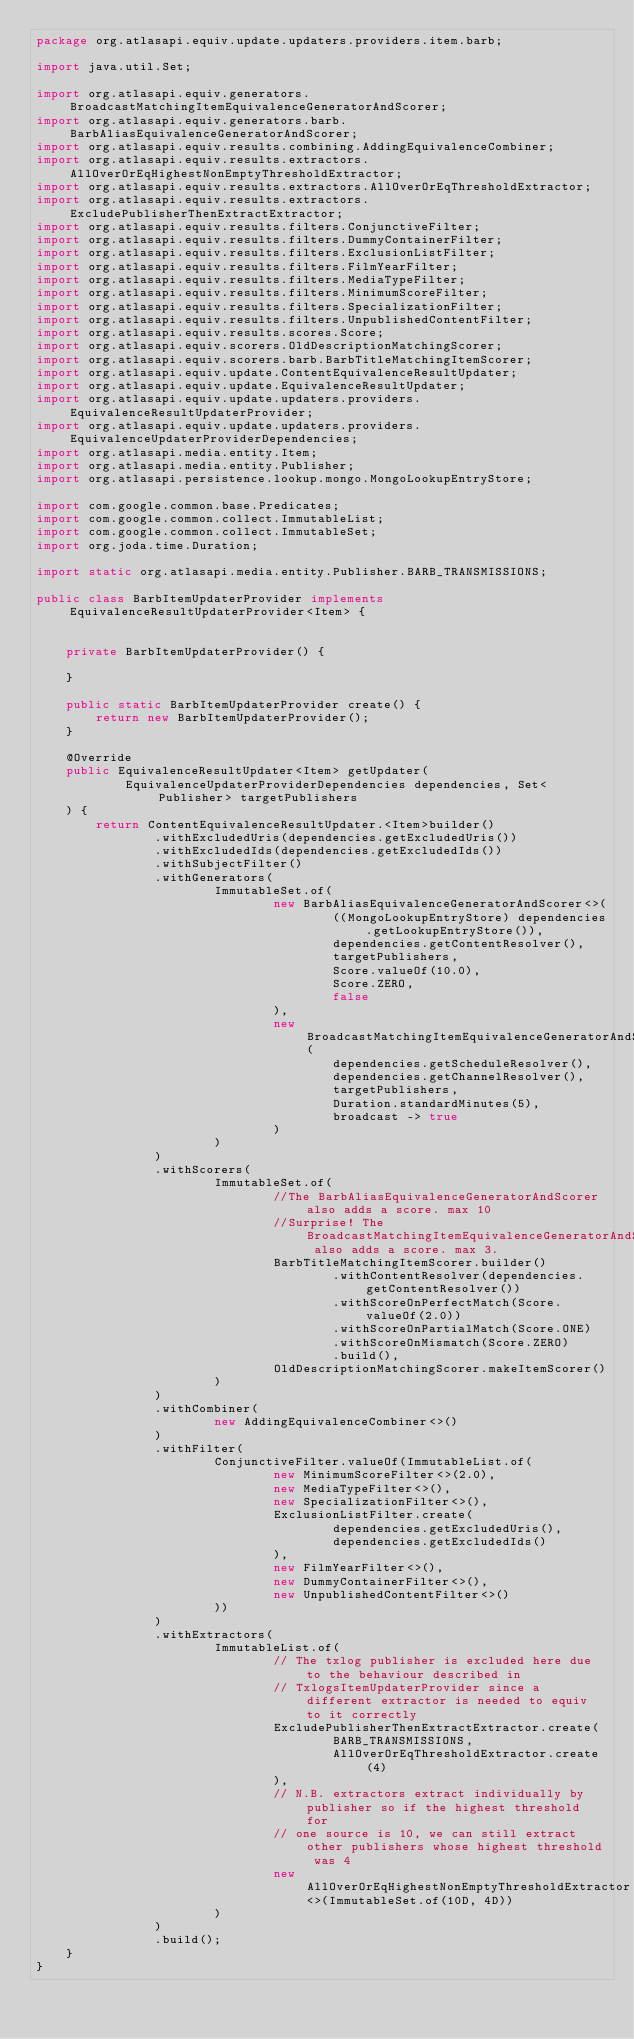<code> <loc_0><loc_0><loc_500><loc_500><_Java_>package org.atlasapi.equiv.update.updaters.providers.item.barb;

import java.util.Set;

import org.atlasapi.equiv.generators.BroadcastMatchingItemEquivalenceGeneratorAndScorer;
import org.atlasapi.equiv.generators.barb.BarbAliasEquivalenceGeneratorAndScorer;
import org.atlasapi.equiv.results.combining.AddingEquivalenceCombiner;
import org.atlasapi.equiv.results.extractors.AllOverOrEqHighestNonEmptyThresholdExtractor;
import org.atlasapi.equiv.results.extractors.AllOverOrEqThresholdExtractor;
import org.atlasapi.equiv.results.extractors.ExcludePublisherThenExtractExtractor;
import org.atlasapi.equiv.results.filters.ConjunctiveFilter;
import org.atlasapi.equiv.results.filters.DummyContainerFilter;
import org.atlasapi.equiv.results.filters.ExclusionListFilter;
import org.atlasapi.equiv.results.filters.FilmYearFilter;
import org.atlasapi.equiv.results.filters.MediaTypeFilter;
import org.atlasapi.equiv.results.filters.MinimumScoreFilter;
import org.atlasapi.equiv.results.filters.SpecializationFilter;
import org.atlasapi.equiv.results.filters.UnpublishedContentFilter;
import org.atlasapi.equiv.results.scores.Score;
import org.atlasapi.equiv.scorers.OldDescriptionMatchingScorer;
import org.atlasapi.equiv.scorers.barb.BarbTitleMatchingItemScorer;
import org.atlasapi.equiv.update.ContentEquivalenceResultUpdater;
import org.atlasapi.equiv.update.EquivalenceResultUpdater;
import org.atlasapi.equiv.update.updaters.providers.EquivalenceResultUpdaterProvider;
import org.atlasapi.equiv.update.updaters.providers.EquivalenceUpdaterProviderDependencies;
import org.atlasapi.media.entity.Item;
import org.atlasapi.media.entity.Publisher;
import org.atlasapi.persistence.lookup.mongo.MongoLookupEntryStore;

import com.google.common.base.Predicates;
import com.google.common.collect.ImmutableList;
import com.google.common.collect.ImmutableSet;
import org.joda.time.Duration;

import static org.atlasapi.media.entity.Publisher.BARB_TRANSMISSIONS;

public class BarbItemUpdaterProvider implements EquivalenceResultUpdaterProvider<Item> {


    private BarbItemUpdaterProvider() {

    }

    public static BarbItemUpdaterProvider create() {
        return new BarbItemUpdaterProvider();
    }

    @Override
    public EquivalenceResultUpdater<Item> getUpdater(
            EquivalenceUpdaterProviderDependencies dependencies, Set<Publisher> targetPublishers
    ) {
        return ContentEquivalenceResultUpdater.<Item>builder()
                .withExcludedUris(dependencies.getExcludedUris())
                .withExcludedIds(dependencies.getExcludedIds())
                .withSubjectFilter()
                .withGenerators(
                        ImmutableSet.of(
                                new BarbAliasEquivalenceGeneratorAndScorer<>(
                                        ((MongoLookupEntryStore) dependencies.getLookupEntryStore()),
                                        dependencies.getContentResolver(),
                                        targetPublishers,
                                        Score.valueOf(10.0),
                                        Score.ZERO,
                                        false
                                ),
                                new BroadcastMatchingItemEquivalenceGeneratorAndScorer(
                                        dependencies.getScheduleResolver(),
                                        dependencies.getChannelResolver(),
                                        targetPublishers,
                                        Duration.standardMinutes(5),
                                        broadcast -> true
                                )
                        )
                )
                .withScorers(
                        ImmutableSet.of(
                                //The BarbAliasEquivalenceGeneratorAndScorer also adds a score. max 10
                                //Surprise! The BroadcastMatchingItemEquivalenceGeneratorAndScorer also adds a score. max 3.
                                BarbTitleMatchingItemScorer.builder()
                                        .withContentResolver(dependencies.getContentResolver())
                                        .withScoreOnPerfectMatch(Score.valueOf(2.0))
                                        .withScoreOnPartialMatch(Score.ONE)
                                        .withScoreOnMismatch(Score.ZERO)
                                        .build(),
                                OldDescriptionMatchingScorer.makeItemScorer()
                        )
                )
                .withCombiner(
                        new AddingEquivalenceCombiner<>()
                )
                .withFilter(
                        ConjunctiveFilter.valueOf(ImmutableList.of(
                                new MinimumScoreFilter<>(2.0),
                                new MediaTypeFilter<>(),
                                new SpecializationFilter<>(),
                                ExclusionListFilter.create(
                                        dependencies.getExcludedUris(),
                                        dependencies.getExcludedIds()
                                ),
                                new FilmYearFilter<>(),
                                new DummyContainerFilter<>(),
                                new UnpublishedContentFilter<>()
                        ))
                )
                .withExtractors(
                        ImmutableList.of(
                                // The txlog publisher is excluded here due to the behaviour described in
                                // TxlogsItemUpdaterProvider since a different extractor is needed to equiv to it correctly
                                ExcludePublisherThenExtractExtractor.create(
                                        BARB_TRANSMISSIONS,
                                        AllOverOrEqThresholdExtractor.create(4)
                                ),
                                // N.B. extractors extract individually by publisher so if the highest threshold for
                                // one source is 10, we can still extract other publishers whose highest threshold was 4
                                new AllOverOrEqHighestNonEmptyThresholdExtractor<>(ImmutableSet.of(10D, 4D))
                        )
                )
                .build();
    }
}
</code> 